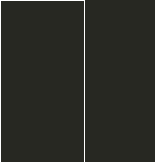<code> <loc_0><loc_0><loc_500><loc_500><_JavaScript_>
</code> 